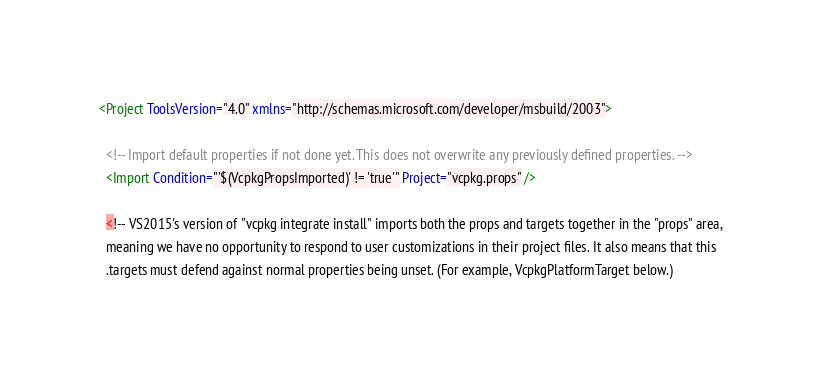Convert code to text. <code><loc_0><loc_0><loc_500><loc_500><_XML_><Project ToolsVersion="4.0" xmlns="http://schemas.microsoft.com/developer/msbuild/2003">

  <!-- Import default properties if not done yet. This does not overwrite any previously defined properties. -->
  <Import Condition="'$(VcpkgPropsImported)' != 'true'" Project="vcpkg.props" />

  <!-- VS2015's version of "vcpkg integrate install" imports both the props and targets together in the "props" area,
  meaning we have no opportunity to respond to user customizations in their project files. It also means that this
  .targets must defend against normal properties being unset. (For example, VcpkgPlatformTarget below.)
</code> 